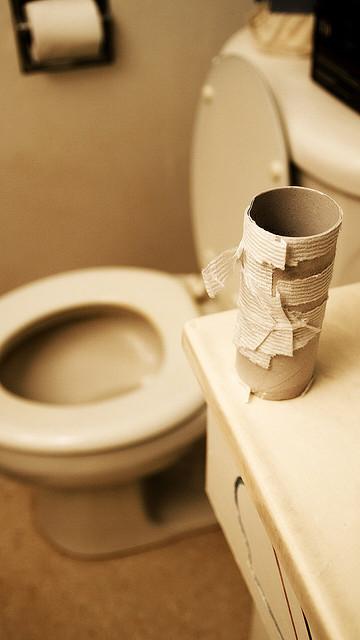The toilet paper is empty?
Give a very brief answer. Yes. What is the pattern of the floor?
Keep it brief. Solid. Is the toilet paper empty?
Concise answer only. Yes. Has anyone replaced the roll of toilet paper?
Give a very brief answer. No. 